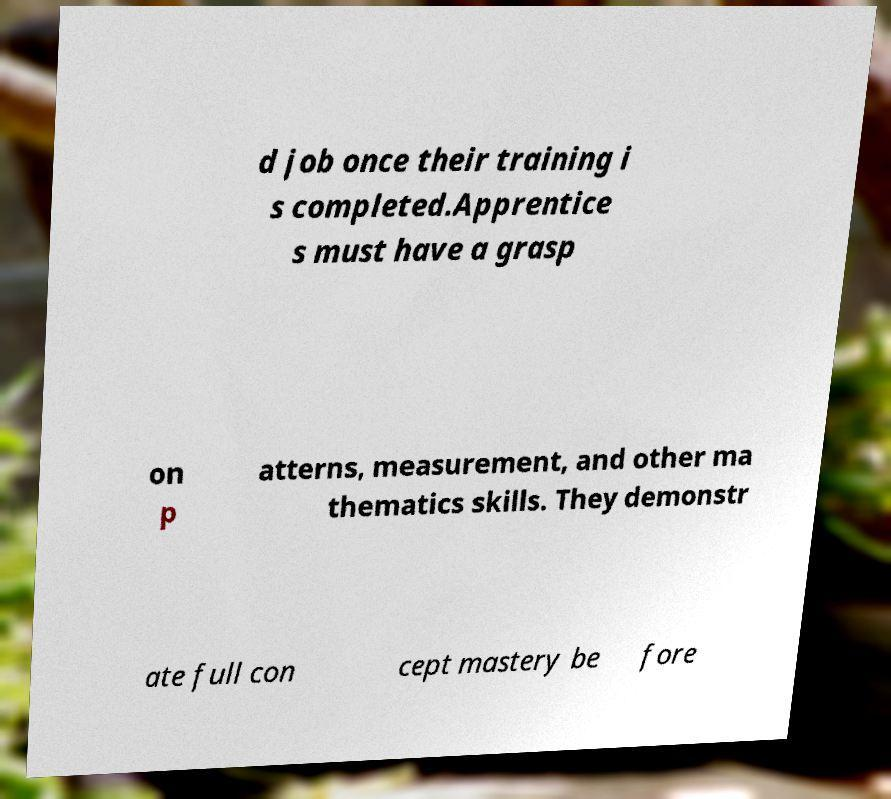For documentation purposes, I need the text within this image transcribed. Could you provide that? d job once their training i s completed.Apprentice s must have a grasp on p atterns, measurement, and other ma thematics skills. They demonstr ate full con cept mastery be fore 